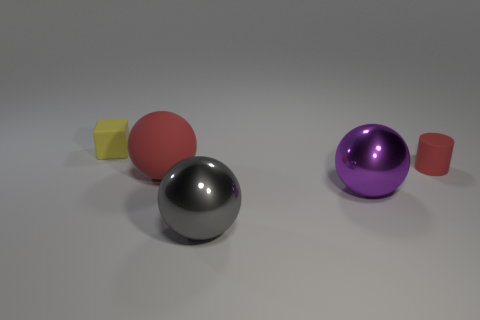Subtract all metal spheres. How many spheres are left? 1 Add 4 red things. How many objects exist? 9 Subtract all spheres. How many objects are left? 2 Subtract all red balls. How many balls are left? 2 Subtract 1 spheres. How many spheres are left? 2 Subtract all large purple objects. Subtract all large gray metallic things. How many objects are left? 3 Add 5 balls. How many balls are left? 8 Add 4 big green rubber cylinders. How many big green rubber cylinders exist? 4 Subtract 0 cyan cubes. How many objects are left? 5 Subtract all green cubes. Subtract all purple cylinders. How many cubes are left? 1 